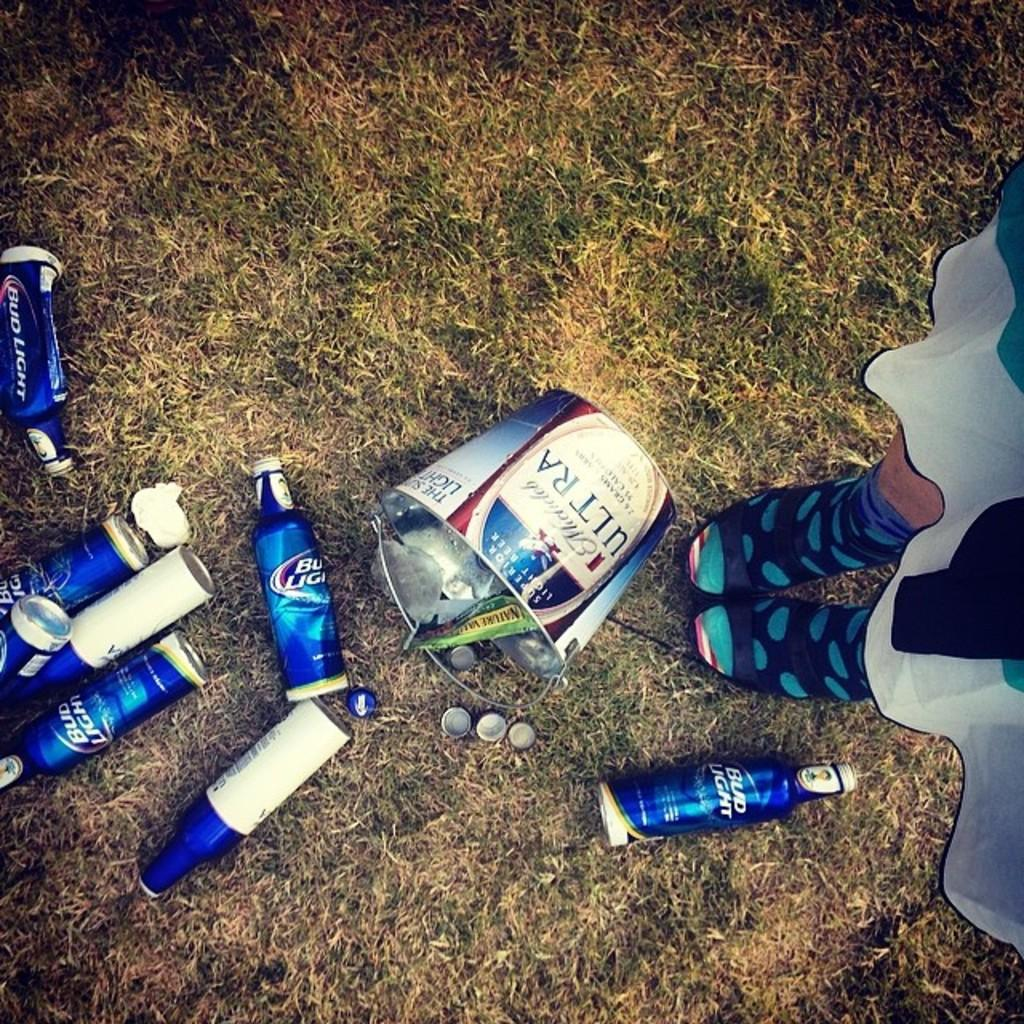<image>
Share a concise interpretation of the image provided. Bottles of Bud Light beer on the grass next to a tin bucket 